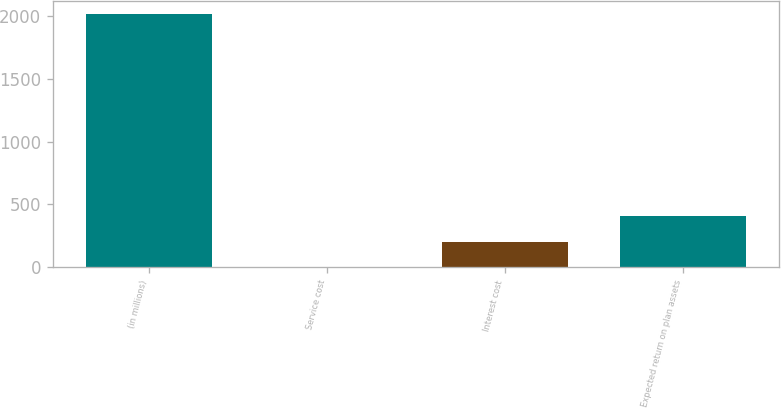<chart> <loc_0><loc_0><loc_500><loc_500><bar_chart><fcel>(in millions)<fcel>Service cost<fcel>Interest cost<fcel>Expected return on plan assets<nl><fcel>2013<fcel>4<fcel>204.9<fcel>405.8<nl></chart> 